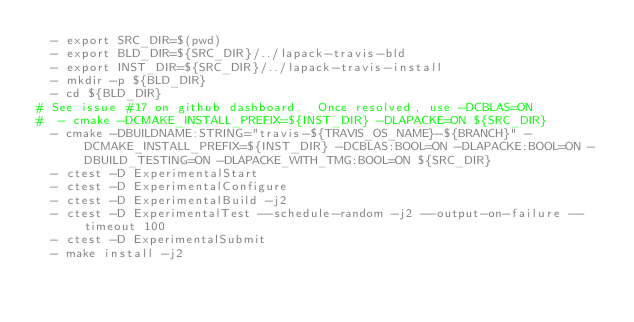Convert code to text. <code><loc_0><loc_0><loc_500><loc_500><_YAML_>  - export SRC_DIR=$(pwd)
  - export BLD_DIR=${SRC_DIR}/../lapack-travis-bld
  - export INST_DIR=${SRC_DIR}/../lapack-travis-install
  - mkdir -p ${BLD_DIR}
  - cd ${BLD_DIR}
# See issue #17 on github dashboard.  Once resolved, use -DCBLAS=ON
#  - cmake -DCMAKE_INSTALL_PREFIX=${INST_DIR} -DLAPACKE=ON ${SRC_DIR}
  - cmake -DBUILDNAME:STRING="travis-${TRAVIS_OS_NAME}-${BRANCH}" -DCMAKE_INSTALL_PREFIX=${INST_DIR} -DCBLAS:BOOL=ON -DLAPACKE:BOOL=ON -DBUILD_TESTING=ON -DLAPACKE_WITH_TMG:BOOL=ON ${SRC_DIR}
  - ctest -D ExperimentalStart
  - ctest -D ExperimentalConfigure
  - ctest -D ExperimentalBuild -j2
  - ctest -D ExperimentalTest --schedule-random -j2 --output-on-failure --timeout 100
  - ctest -D ExperimentalSubmit
  - make install -j2
</code> 